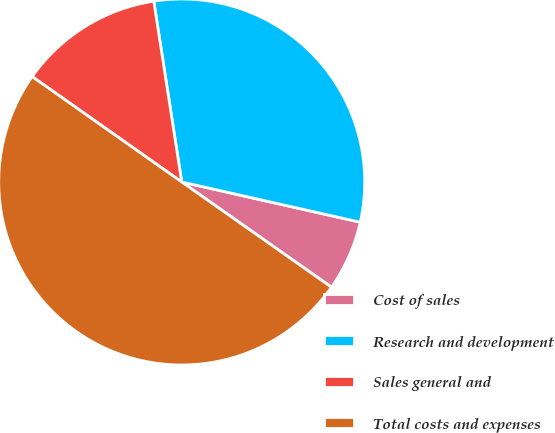Convert chart. <chart><loc_0><loc_0><loc_500><loc_500><pie_chart><fcel>Cost of sales<fcel>Research and development<fcel>Sales general and<fcel>Total costs and expenses<nl><fcel>6.22%<fcel>30.97%<fcel>12.79%<fcel>50.02%<nl></chart> 